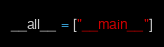Convert code to text. <code><loc_0><loc_0><loc_500><loc_500><_Python_>
__all__ = ["__main__"]</code> 